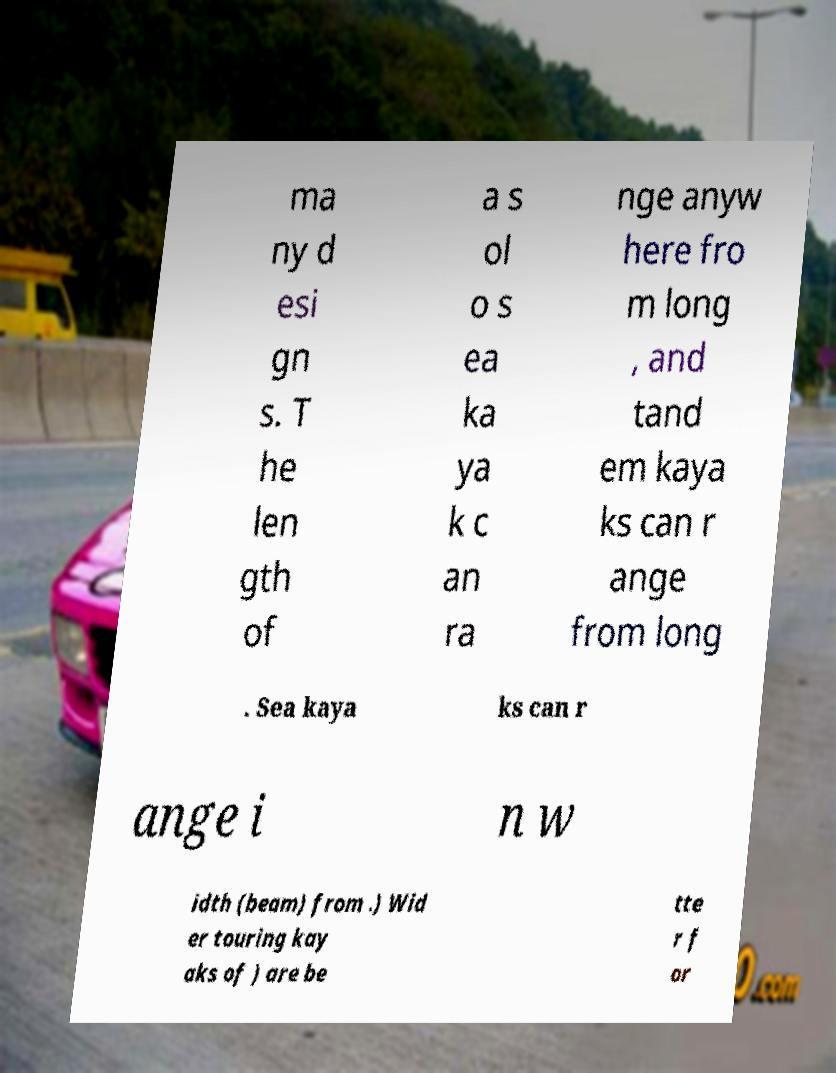Please identify and transcribe the text found in this image. ma ny d esi gn s. T he len gth of a s ol o s ea ka ya k c an ra nge anyw here fro m long , and tand em kaya ks can r ange from long . Sea kaya ks can r ange i n w idth (beam) from .) Wid er touring kay aks of ) are be tte r f or 